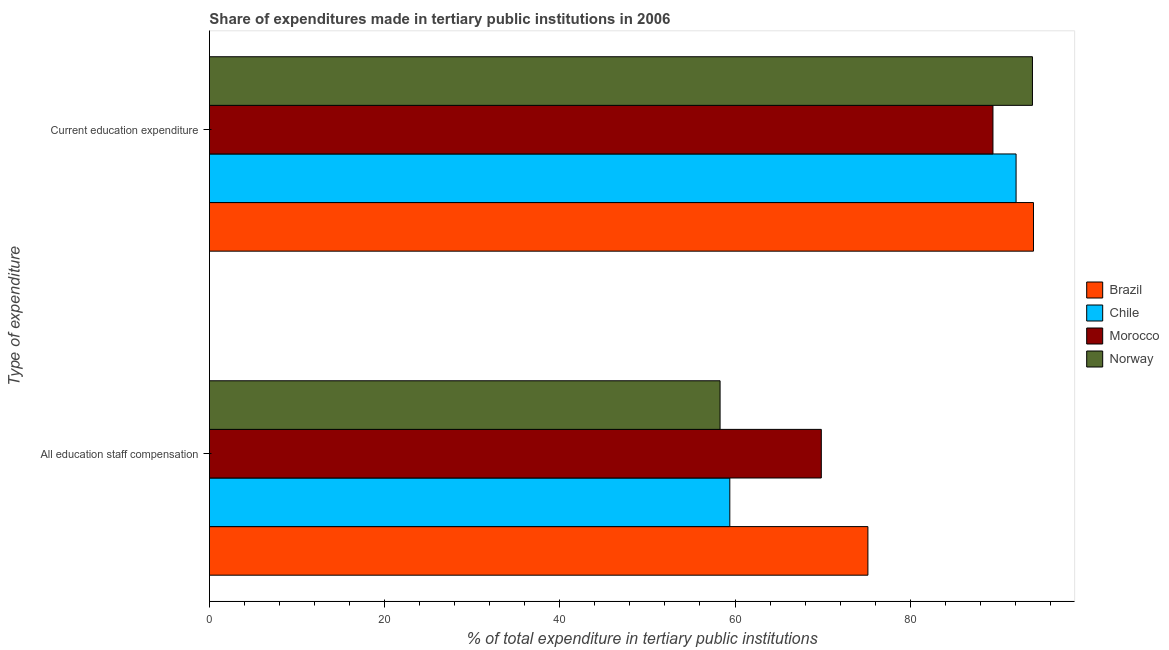How many groups of bars are there?
Keep it short and to the point. 2. Are the number of bars per tick equal to the number of legend labels?
Provide a succinct answer. Yes. What is the label of the 1st group of bars from the top?
Your response must be concise. Current education expenditure. What is the expenditure in education in Morocco?
Your answer should be compact. 89.45. Across all countries, what is the maximum expenditure in education?
Keep it short and to the point. 94.07. Across all countries, what is the minimum expenditure in education?
Offer a very short reply. 89.45. In which country was the expenditure in education minimum?
Your answer should be compact. Morocco. What is the total expenditure in education in the graph?
Offer a terse response. 369.56. What is the difference between the expenditure in staff compensation in Norway and that in Brazil?
Offer a terse response. -16.87. What is the difference between the expenditure in staff compensation in Chile and the expenditure in education in Morocco?
Offer a terse response. -30.04. What is the average expenditure in education per country?
Your response must be concise. 92.39. What is the difference between the expenditure in education and expenditure in staff compensation in Norway?
Provide a succinct answer. 35.66. In how many countries, is the expenditure in staff compensation greater than 44 %?
Ensure brevity in your answer.  4. What is the ratio of the expenditure in staff compensation in Chile to that in Morocco?
Provide a short and direct response. 0.85. In how many countries, is the expenditure in education greater than the average expenditure in education taken over all countries?
Keep it short and to the point. 2. What does the 3rd bar from the bottom in Current education expenditure represents?
Make the answer very short. Morocco. How many countries are there in the graph?
Keep it short and to the point. 4. What is the difference between two consecutive major ticks on the X-axis?
Your response must be concise. 20. Are the values on the major ticks of X-axis written in scientific E-notation?
Make the answer very short. No. Where does the legend appear in the graph?
Ensure brevity in your answer.  Center right. How many legend labels are there?
Offer a very short reply. 4. What is the title of the graph?
Keep it short and to the point. Share of expenditures made in tertiary public institutions in 2006. Does "New Caledonia" appear as one of the legend labels in the graph?
Your answer should be very brief. No. What is the label or title of the X-axis?
Offer a very short reply. % of total expenditure in tertiary public institutions. What is the label or title of the Y-axis?
Keep it short and to the point. Type of expenditure. What is the % of total expenditure in tertiary public institutions of Brazil in All education staff compensation?
Your response must be concise. 75.17. What is the % of total expenditure in tertiary public institutions in Chile in All education staff compensation?
Provide a succinct answer. 59.41. What is the % of total expenditure in tertiary public institutions in Morocco in All education staff compensation?
Your answer should be very brief. 69.85. What is the % of total expenditure in tertiary public institutions in Norway in All education staff compensation?
Provide a short and direct response. 58.29. What is the % of total expenditure in tertiary public institutions in Brazil in Current education expenditure?
Offer a terse response. 94.07. What is the % of total expenditure in tertiary public institutions in Chile in Current education expenditure?
Provide a succinct answer. 92.09. What is the % of total expenditure in tertiary public institutions in Morocco in Current education expenditure?
Keep it short and to the point. 89.45. What is the % of total expenditure in tertiary public institutions of Norway in Current education expenditure?
Ensure brevity in your answer.  93.95. Across all Type of expenditure, what is the maximum % of total expenditure in tertiary public institutions of Brazil?
Offer a terse response. 94.07. Across all Type of expenditure, what is the maximum % of total expenditure in tertiary public institutions of Chile?
Your answer should be very brief. 92.09. Across all Type of expenditure, what is the maximum % of total expenditure in tertiary public institutions of Morocco?
Offer a terse response. 89.45. Across all Type of expenditure, what is the maximum % of total expenditure in tertiary public institutions in Norway?
Give a very brief answer. 93.95. Across all Type of expenditure, what is the minimum % of total expenditure in tertiary public institutions in Brazil?
Your response must be concise. 75.17. Across all Type of expenditure, what is the minimum % of total expenditure in tertiary public institutions of Chile?
Give a very brief answer. 59.41. Across all Type of expenditure, what is the minimum % of total expenditure in tertiary public institutions of Morocco?
Your response must be concise. 69.85. Across all Type of expenditure, what is the minimum % of total expenditure in tertiary public institutions in Norway?
Make the answer very short. 58.29. What is the total % of total expenditure in tertiary public institutions in Brazil in the graph?
Your answer should be very brief. 169.24. What is the total % of total expenditure in tertiary public institutions in Chile in the graph?
Keep it short and to the point. 151.49. What is the total % of total expenditure in tertiary public institutions in Morocco in the graph?
Offer a very short reply. 159.3. What is the total % of total expenditure in tertiary public institutions of Norway in the graph?
Make the answer very short. 152.25. What is the difference between the % of total expenditure in tertiary public institutions of Brazil in All education staff compensation and that in Current education expenditure?
Your answer should be compact. -18.9. What is the difference between the % of total expenditure in tertiary public institutions of Chile in All education staff compensation and that in Current education expenditure?
Ensure brevity in your answer.  -32.68. What is the difference between the % of total expenditure in tertiary public institutions of Morocco in All education staff compensation and that in Current education expenditure?
Provide a short and direct response. -19.59. What is the difference between the % of total expenditure in tertiary public institutions in Norway in All education staff compensation and that in Current education expenditure?
Make the answer very short. -35.66. What is the difference between the % of total expenditure in tertiary public institutions in Brazil in All education staff compensation and the % of total expenditure in tertiary public institutions in Chile in Current education expenditure?
Keep it short and to the point. -16.92. What is the difference between the % of total expenditure in tertiary public institutions of Brazil in All education staff compensation and the % of total expenditure in tertiary public institutions of Morocco in Current education expenditure?
Offer a terse response. -14.28. What is the difference between the % of total expenditure in tertiary public institutions in Brazil in All education staff compensation and the % of total expenditure in tertiary public institutions in Norway in Current education expenditure?
Offer a very short reply. -18.78. What is the difference between the % of total expenditure in tertiary public institutions in Chile in All education staff compensation and the % of total expenditure in tertiary public institutions in Morocco in Current education expenditure?
Your response must be concise. -30.04. What is the difference between the % of total expenditure in tertiary public institutions in Chile in All education staff compensation and the % of total expenditure in tertiary public institutions in Norway in Current education expenditure?
Your answer should be very brief. -34.55. What is the difference between the % of total expenditure in tertiary public institutions of Morocco in All education staff compensation and the % of total expenditure in tertiary public institutions of Norway in Current education expenditure?
Your answer should be compact. -24.1. What is the average % of total expenditure in tertiary public institutions in Brazil per Type of expenditure?
Offer a terse response. 84.62. What is the average % of total expenditure in tertiary public institutions in Chile per Type of expenditure?
Offer a very short reply. 75.75. What is the average % of total expenditure in tertiary public institutions of Morocco per Type of expenditure?
Offer a terse response. 79.65. What is the average % of total expenditure in tertiary public institutions in Norway per Type of expenditure?
Ensure brevity in your answer.  76.12. What is the difference between the % of total expenditure in tertiary public institutions in Brazil and % of total expenditure in tertiary public institutions in Chile in All education staff compensation?
Your response must be concise. 15.76. What is the difference between the % of total expenditure in tertiary public institutions of Brazil and % of total expenditure in tertiary public institutions of Morocco in All education staff compensation?
Offer a very short reply. 5.32. What is the difference between the % of total expenditure in tertiary public institutions of Brazil and % of total expenditure in tertiary public institutions of Norway in All education staff compensation?
Offer a terse response. 16.88. What is the difference between the % of total expenditure in tertiary public institutions in Chile and % of total expenditure in tertiary public institutions in Morocco in All education staff compensation?
Your response must be concise. -10.44. What is the difference between the % of total expenditure in tertiary public institutions of Chile and % of total expenditure in tertiary public institutions of Norway in All education staff compensation?
Your response must be concise. 1.11. What is the difference between the % of total expenditure in tertiary public institutions in Morocco and % of total expenditure in tertiary public institutions in Norway in All education staff compensation?
Provide a short and direct response. 11.56. What is the difference between the % of total expenditure in tertiary public institutions of Brazil and % of total expenditure in tertiary public institutions of Chile in Current education expenditure?
Provide a short and direct response. 1.99. What is the difference between the % of total expenditure in tertiary public institutions of Brazil and % of total expenditure in tertiary public institutions of Morocco in Current education expenditure?
Provide a short and direct response. 4.63. What is the difference between the % of total expenditure in tertiary public institutions in Brazil and % of total expenditure in tertiary public institutions in Norway in Current education expenditure?
Offer a very short reply. 0.12. What is the difference between the % of total expenditure in tertiary public institutions of Chile and % of total expenditure in tertiary public institutions of Morocco in Current education expenditure?
Offer a very short reply. 2.64. What is the difference between the % of total expenditure in tertiary public institutions of Chile and % of total expenditure in tertiary public institutions of Norway in Current education expenditure?
Your answer should be compact. -1.87. What is the difference between the % of total expenditure in tertiary public institutions of Morocco and % of total expenditure in tertiary public institutions of Norway in Current education expenditure?
Provide a short and direct response. -4.51. What is the ratio of the % of total expenditure in tertiary public institutions of Brazil in All education staff compensation to that in Current education expenditure?
Ensure brevity in your answer.  0.8. What is the ratio of the % of total expenditure in tertiary public institutions in Chile in All education staff compensation to that in Current education expenditure?
Keep it short and to the point. 0.65. What is the ratio of the % of total expenditure in tertiary public institutions in Morocco in All education staff compensation to that in Current education expenditure?
Your response must be concise. 0.78. What is the ratio of the % of total expenditure in tertiary public institutions in Norway in All education staff compensation to that in Current education expenditure?
Ensure brevity in your answer.  0.62. What is the difference between the highest and the second highest % of total expenditure in tertiary public institutions in Brazil?
Keep it short and to the point. 18.9. What is the difference between the highest and the second highest % of total expenditure in tertiary public institutions in Chile?
Your answer should be compact. 32.68. What is the difference between the highest and the second highest % of total expenditure in tertiary public institutions in Morocco?
Provide a short and direct response. 19.59. What is the difference between the highest and the second highest % of total expenditure in tertiary public institutions in Norway?
Provide a short and direct response. 35.66. What is the difference between the highest and the lowest % of total expenditure in tertiary public institutions in Brazil?
Give a very brief answer. 18.9. What is the difference between the highest and the lowest % of total expenditure in tertiary public institutions of Chile?
Provide a succinct answer. 32.68. What is the difference between the highest and the lowest % of total expenditure in tertiary public institutions of Morocco?
Provide a succinct answer. 19.59. What is the difference between the highest and the lowest % of total expenditure in tertiary public institutions of Norway?
Provide a succinct answer. 35.66. 